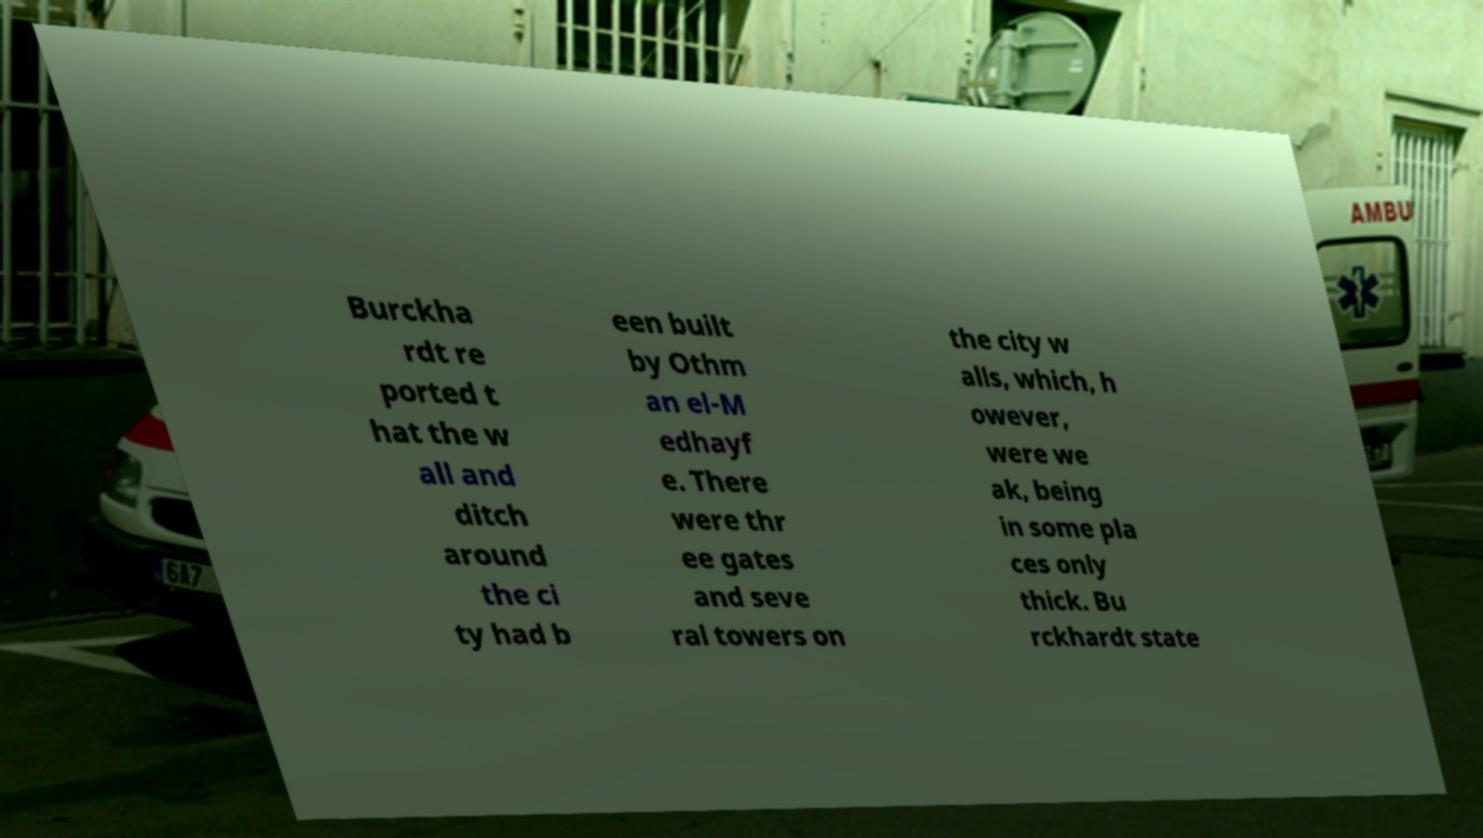Please identify and transcribe the text found in this image. Burckha rdt re ported t hat the w all and ditch around the ci ty had b een built by Othm an el-M edhayf e. There were thr ee gates and seve ral towers on the city w alls, which, h owever, were we ak, being in some pla ces only thick. Bu rckhardt state 